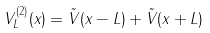Convert formula to latex. <formula><loc_0><loc_0><loc_500><loc_500>V ^ { ( 2 ) } _ { L } ( x ) = \tilde { V } ( x - L ) + \tilde { V } ( x + L )</formula> 